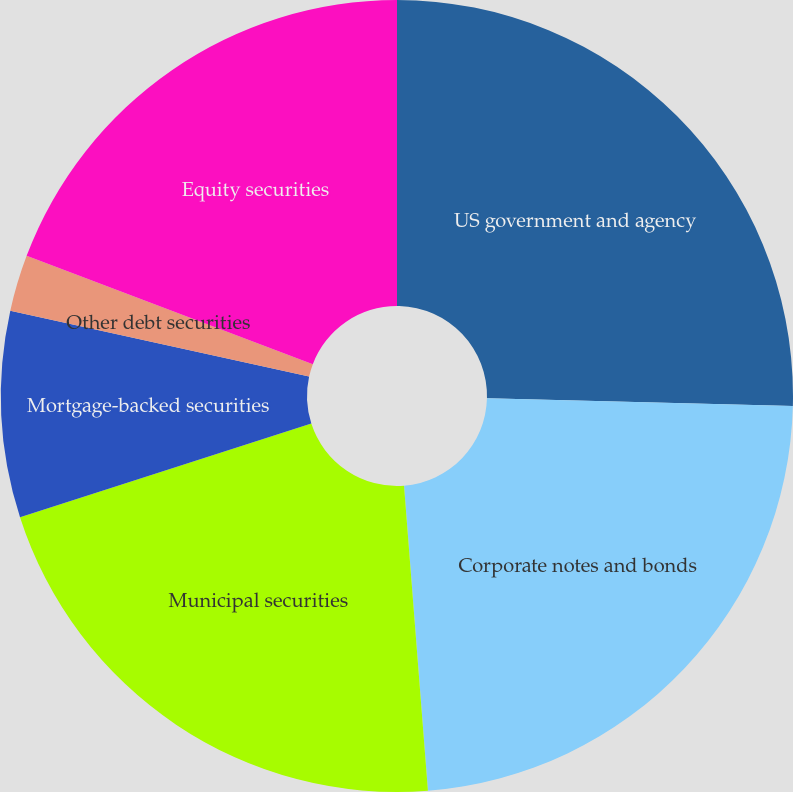<chart> <loc_0><loc_0><loc_500><loc_500><pie_chart><fcel>US government and agency<fcel>Corporate notes and bonds<fcel>Municipal securities<fcel>Mortgage-backed securities<fcel>Other debt securities<fcel>Equity securities<nl><fcel>25.4%<fcel>23.35%<fcel>21.29%<fcel>8.41%<fcel>2.3%<fcel>19.24%<nl></chart> 